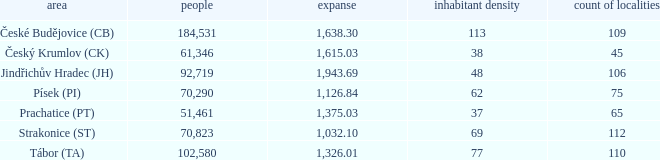What is the population with an area of 1,126.84? 70290.0. 